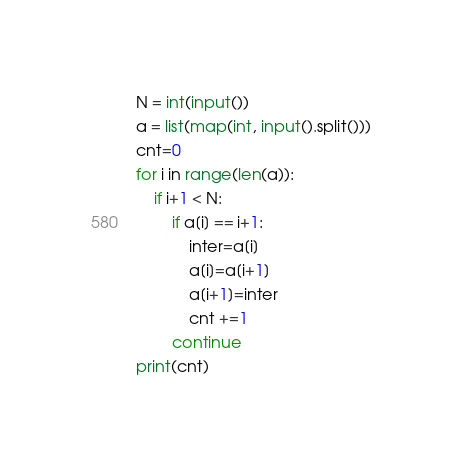Convert code to text. <code><loc_0><loc_0><loc_500><loc_500><_Python_>N = int(input())
a = list(map(int, input().split()))
cnt=0
for i in range(len(a)):
    if i+1 < N:
        if a[i] == i+1:
            inter=a[i]
            a[i]=a[i+1]
            a[i+1]=inter
            cnt +=1
        continue
print(cnt)</code> 